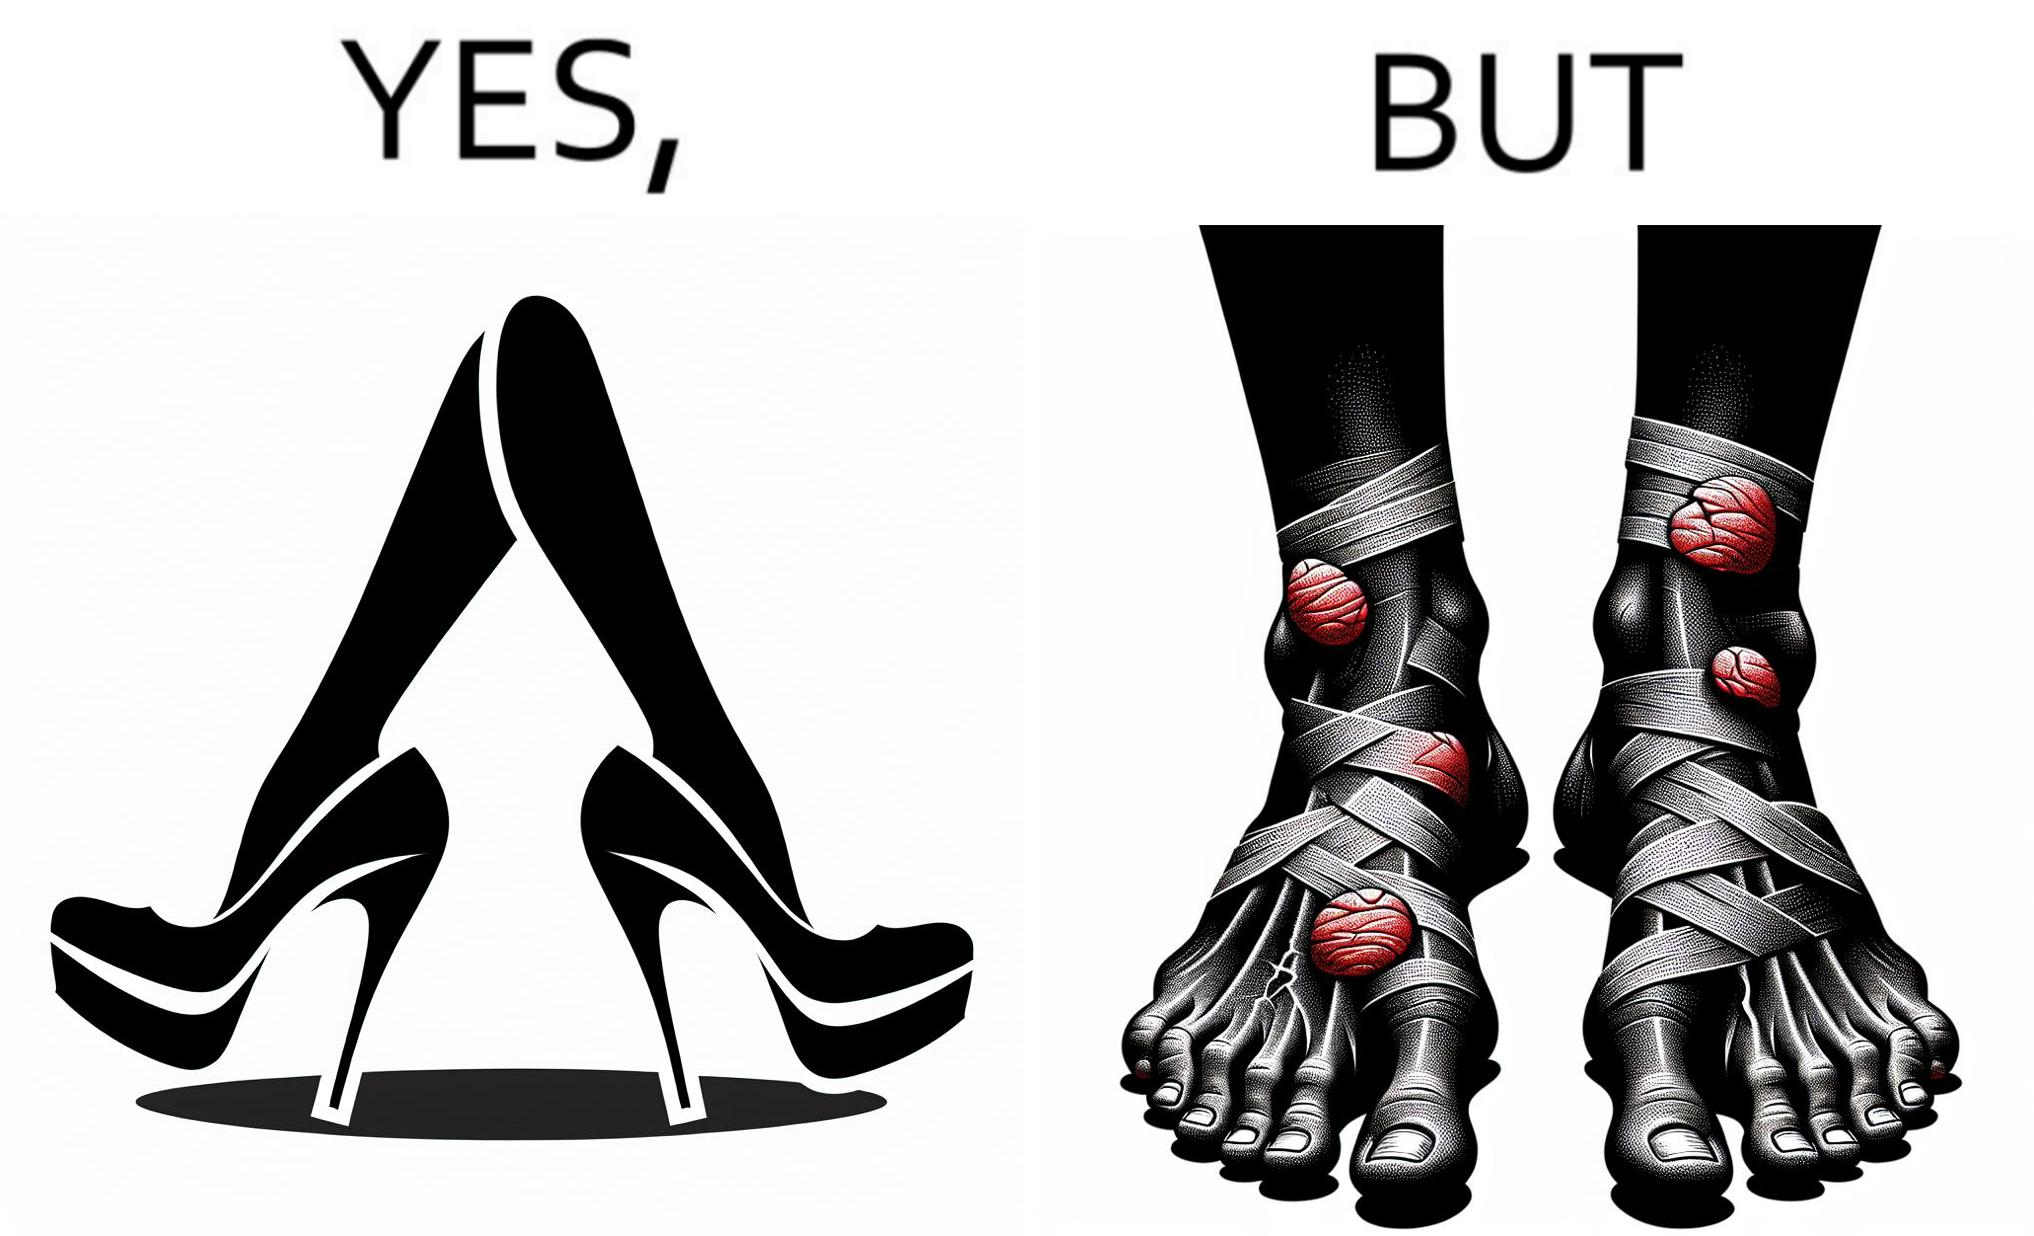Is this a satirical image? Yes, this image is satirical. 